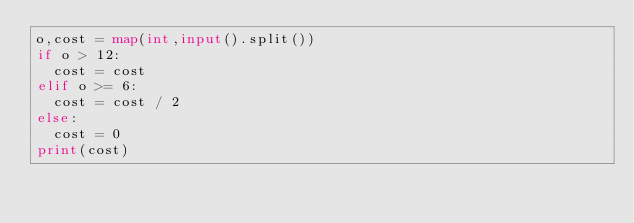<code> <loc_0><loc_0><loc_500><loc_500><_Python_>o,cost = map(int,input().split())
if o > 12:
  cost = cost
elif o >= 6:
  cost = cost / 2
else:
  cost = 0
print(cost)</code> 